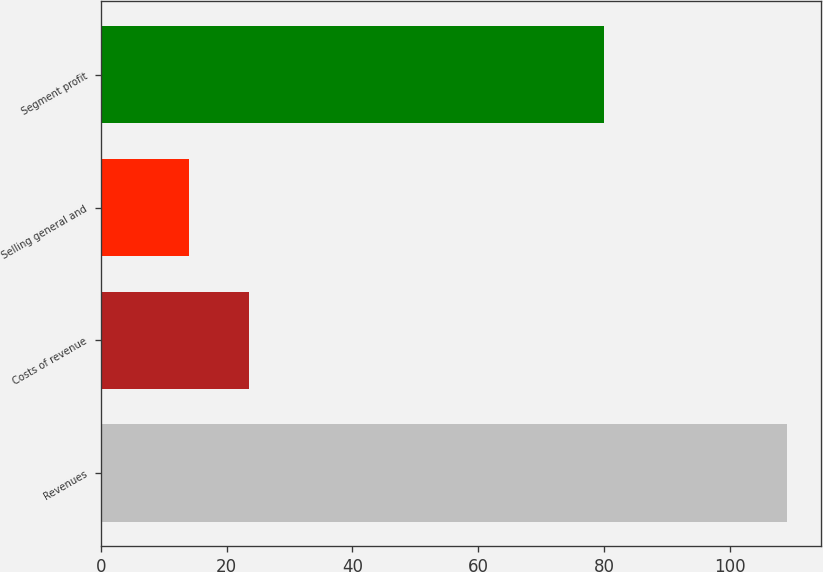Convert chart. <chart><loc_0><loc_0><loc_500><loc_500><bar_chart><fcel>Revenues<fcel>Costs of revenue<fcel>Selling general and<fcel>Segment profit<nl><fcel>109<fcel>23.5<fcel>14<fcel>80<nl></chart> 